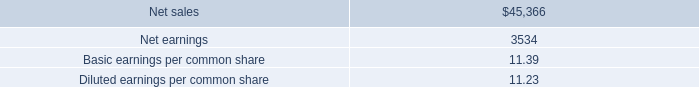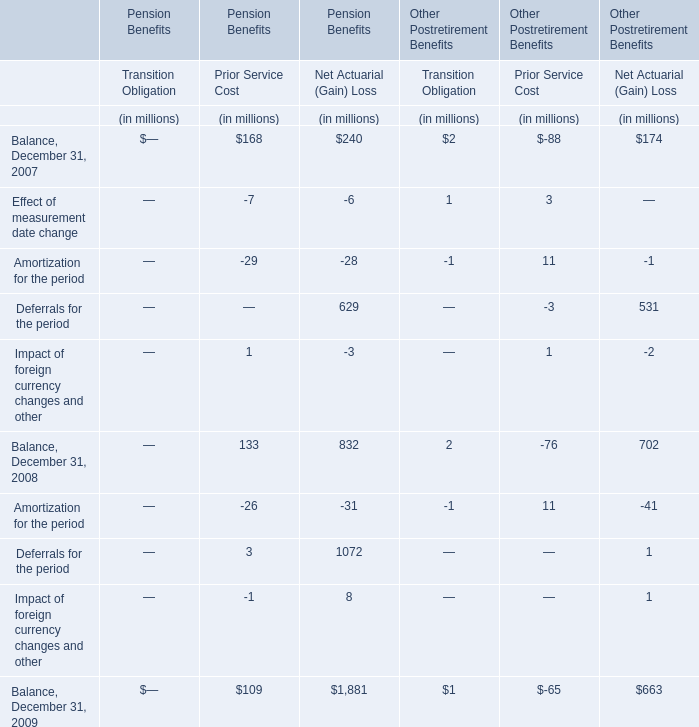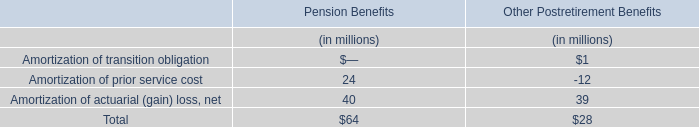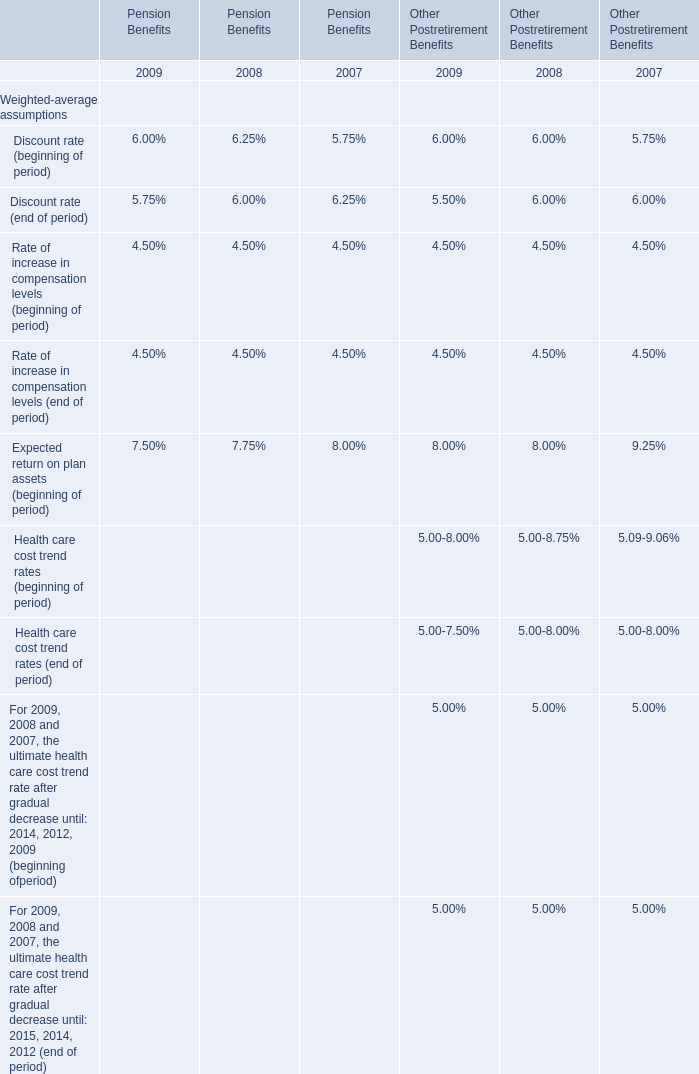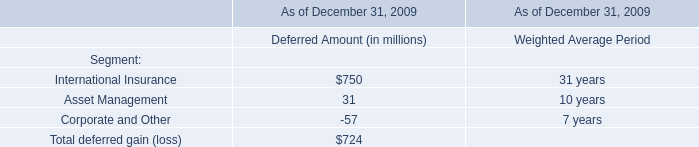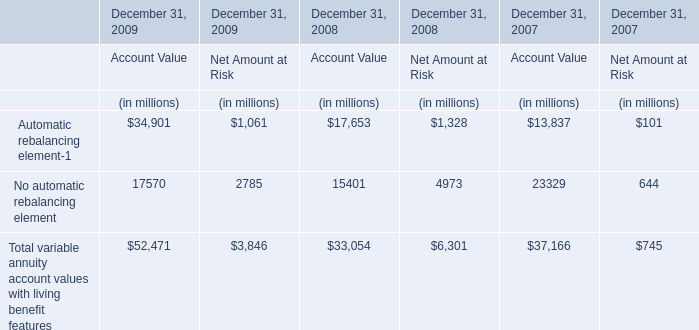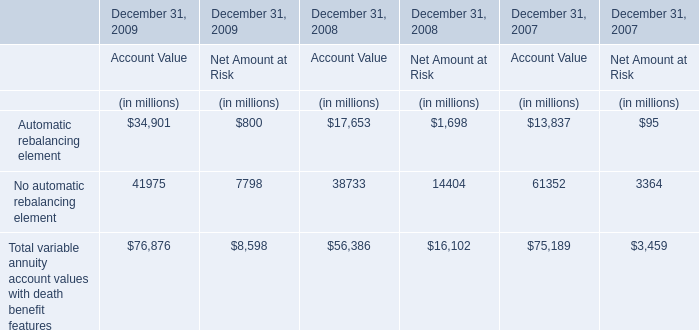What's the average of Transition Obligation Prior Service Cost Net Actuarial (Gain) Loss in 2007? 
Computations: ((168 + 240) / 2)
Answer: 204.0. 